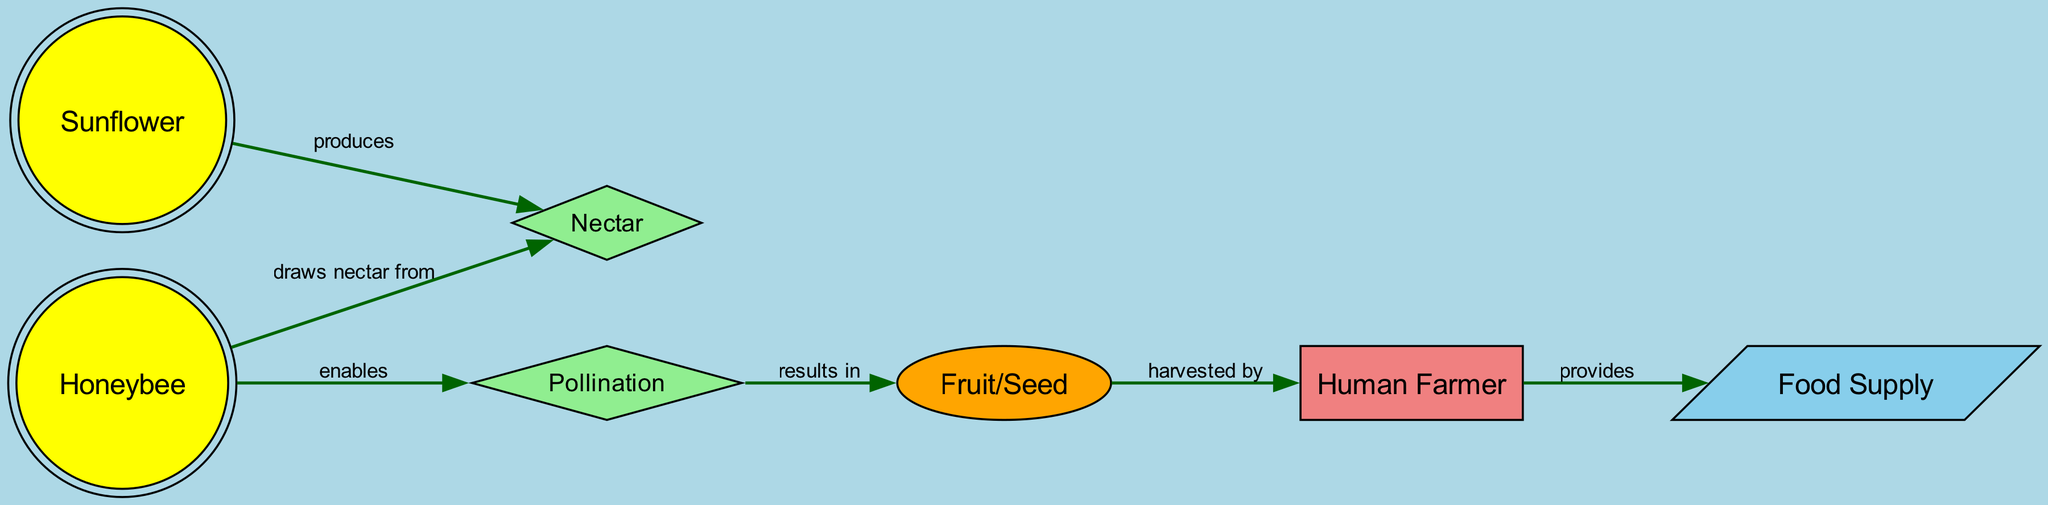What is the first node in the food chain? The first node in the food chain is identified by the flow starting from the Sunflower, which produces nectar. It is the primary producer in this food chain.
Answer: Sunflower How many nodes are in the diagram? By counting all the unique entities present, we find there are a total of seven nodes: Sunflower, Honeybee, Nectar, Pollination, Fruit/Seed, Human Farmer, and Food Supply.
Answer: 7 What relationship does the Honeybee have with Nectar? The Honeybee draws nectar from the Sunflower, establishing a direct relationship with the nectar produced by the flower. This is represented by a directed edge in the diagram.
Answer: draws nectar from What results from Pollination? Pollination, which is enabled by the Honeybee as it visits the Sunflower, results in the production of Fruit or Seed, meaning the processes demonstrate a dependency.
Answer: Fruit/Seed Who is responsible for harvesting the Fruit/Seed? The Human Farmer is depicted as the one who harvests the Fruit or Seed, indicating a direct interaction with the agricultural output of the food chain.
Answer: Human Farmer What does the Human Farmer provide? The Human Farmer, after harvesting, provides a Food Supply, which is the end product of this agricultural food chain representing the end benefit for humans from the process.
Answer: Food Supply How does the Honeybee contribute to the food chain? The Honeybee enables the process of Pollination, which is critical to the production of the Fruit or Seed, showing its integral role in this food chain's ecology and agriculture.
Answer: enables What type of node is Nectar classified as? In the diagram, Nectar is represented as a diamond-shaped node, which reflects its role as a process or a resource within the food chain, unlike the other nodes.
Answer: diamond 